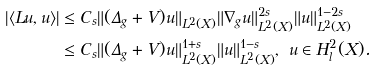Convert formula to latex. <formula><loc_0><loc_0><loc_500><loc_500>| \langle L u , u \rangle | & \leq C _ { s } \| ( \Delta _ { g } + V ) u \| _ { L ^ { 2 } ( X ) } \| \nabla _ { g } u \| ^ { 2 s } _ { L ^ { 2 } ( X ) } \| u \| ^ { 1 - 2 s } _ { L ^ { 2 } ( X ) } \\ & \leq C _ { s } \| ( \Delta _ { g } + V ) u \| _ { L ^ { 2 } ( X ) } ^ { 1 + s } \| u \| ^ { 1 - s } _ { L ^ { 2 } ( X ) } , \ u \in H ^ { 2 } _ { l } ( X ) .</formula> 